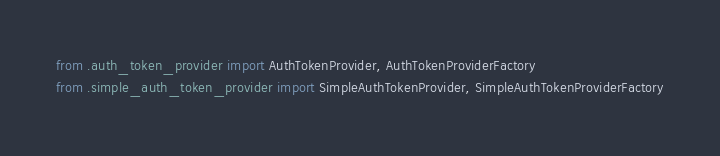<code> <loc_0><loc_0><loc_500><loc_500><_Python_>from .auth_token_provider import AuthTokenProvider, AuthTokenProviderFactory
from .simple_auth_token_provider import SimpleAuthTokenProvider, SimpleAuthTokenProviderFactory
</code> 